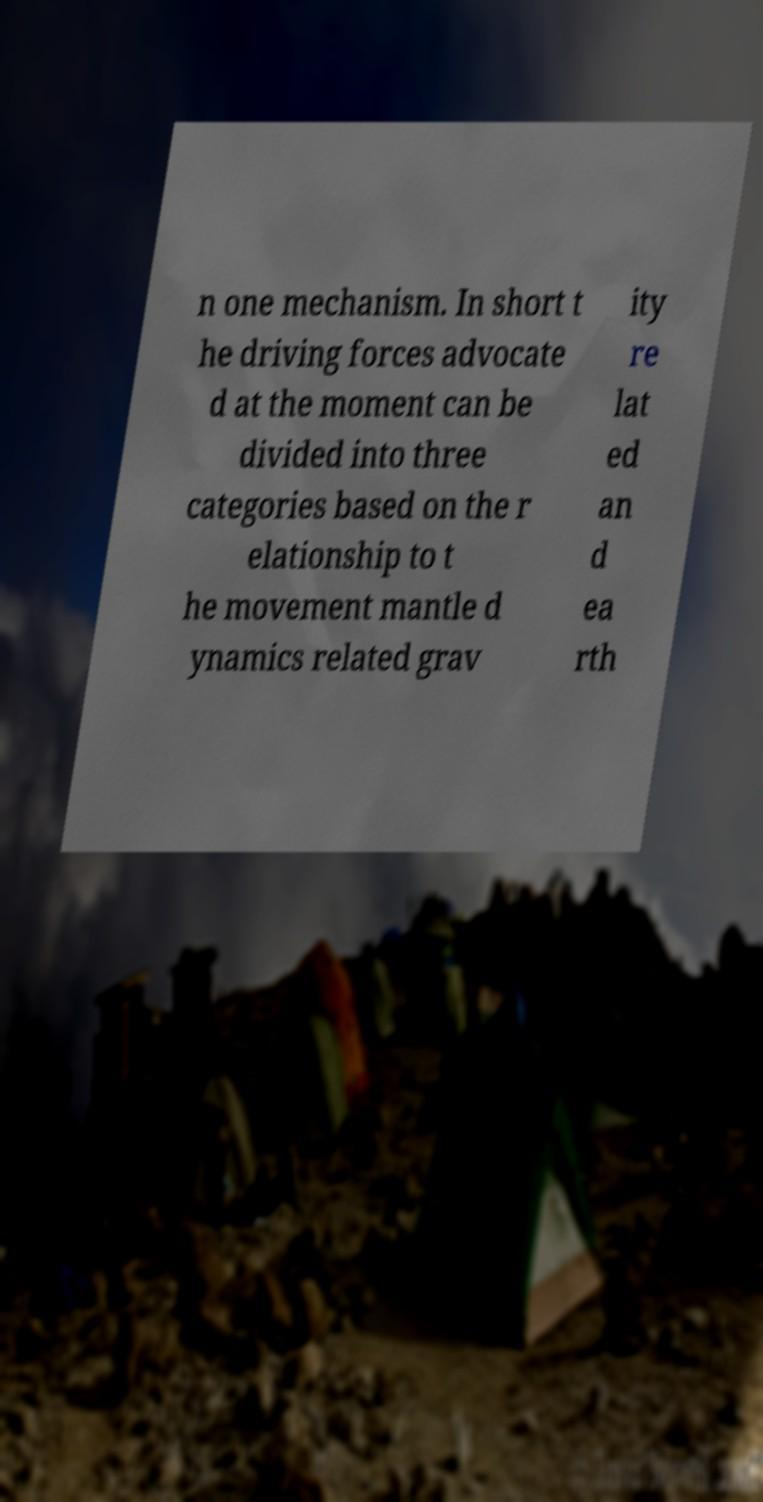What messages or text are displayed in this image? I need them in a readable, typed format. n one mechanism. In short t he driving forces advocate d at the moment can be divided into three categories based on the r elationship to t he movement mantle d ynamics related grav ity re lat ed an d ea rth 